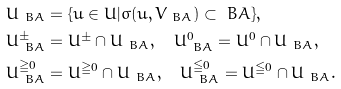<formula> <loc_0><loc_0><loc_500><loc_500>& U _ { \ B A } = \{ u \in U | \sigma ( u , V _ { \ B A } ) \subset { \ B A } \} , \\ & U _ { \ B A } ^ { \pm } = U ^ { \pm } \cap U _ { \ B A } , \quad U _ { \ B A } ^ { 0 } = U ^ { 0 } \cap U _ { \ B A } , \\ & U _ { \ B A } ^ { \geqq 0 } = U ^ { \geqq 0 } \cap U _ { \ B A } , \quad U _ { \ B A } ^ { \leqq 0 } = U ^ { \leqq 0 } \cap U _ { \ B A } .</formula> 